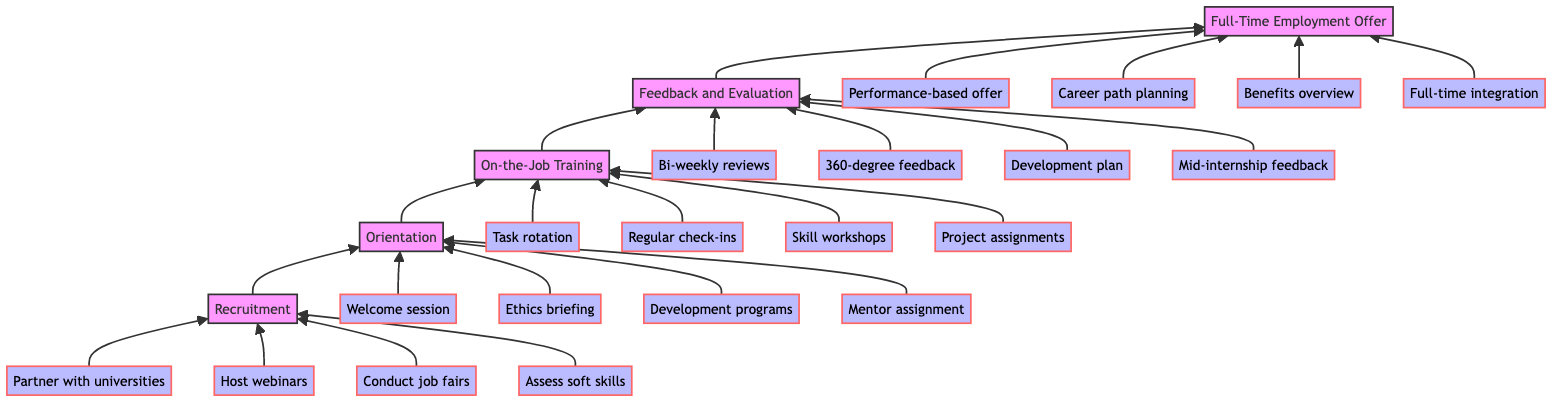What is the topmost stage in the diagram? The topmost stage in the bottom-to-top flow chart is "Full-Time Employment Offer," which indicates the final outcome of the internship model.
Answer: Full-Time Employment Offer How many key actions are associated with the Orientation stage? In the Orientation stage, there are four key actions listed: welcome session, ethics briefing, development programs, and mentor assignment.
Answer: 4 What stage comes after On-the-Job Training? The stage that comes after On-the-Job Training is "Feedback and Evaluation," which focuses on providing constructive feedback to interns.
Answer: Feedback and Evaluation What key action is linked to the Recruitment stage? The key actions linked to the Recruitment stage include several initiatives such as partnering with universities, hosting webinars, conducting job fairs, and assessing soft skills, with one example being "Partner with universities."
Answer: Partner with universities What is the relationship between Feedback and Evaluation and Full-Time Employment Offer stages? The relationship is sequential; after the "Feedback and Evaluation" stage, if the intern meets performance expectations, they move on to the "Full-Time Employment Offer" stage for potential employment.
Answer: Sequential relationship What number of nodes are present in this flowchart? The diagram contains five main stages as nodes: Recruitment, Orientation, On-the-Job Training, Feedback and Evaluation, and Full-Time Employment Offer, making a total of five nodes.
Answer: 5 What is the primary focus of the On-the-Job Training stage? The primary focus of the On-the-Job Training stage is to provide hands-on experience and mentorship to help interns develop practical skills and knowledge in their respective fields.
Answer: Hands-on experience and mentorship How does the organization view the interns throughout the process? The organization views interns through a lens of providing second chances and opportunities for professional growth, with an emphasis on mentorship and feedback.
Answer: Second chances and professional growth What is the first stage in the internship model? The first stage in the internship model is "Recruitment," where the organization identifies and attracts recent graduates for internships.
Answer: Recruitment 